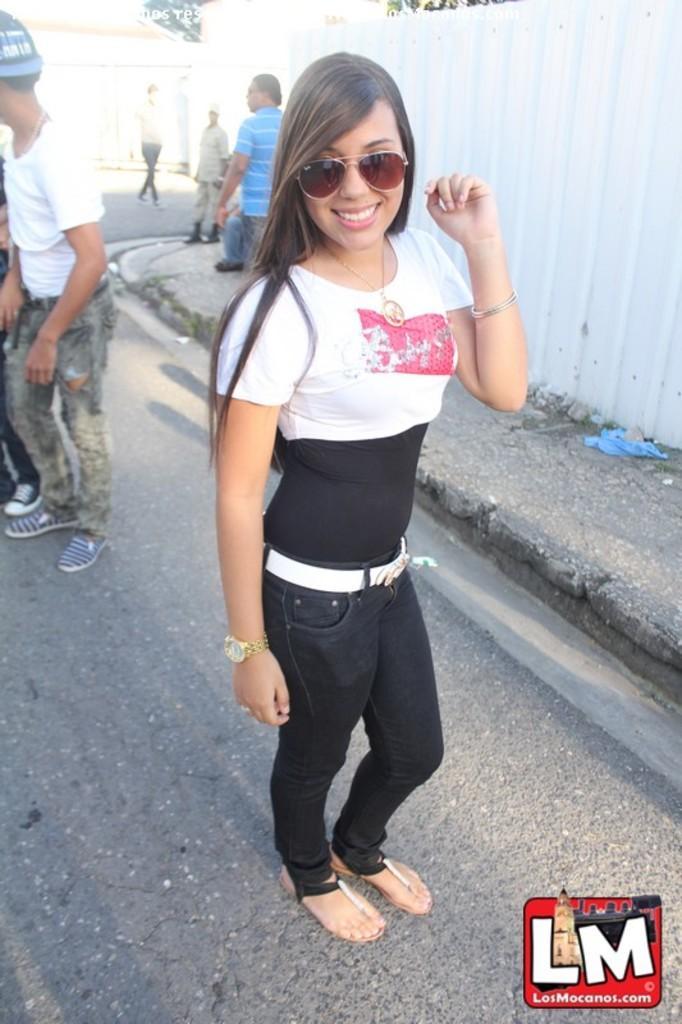How would you summarize this image in a sentence or two? In the center of the picture there is a woman standing. On the left there are people standing. In the background there are people walking down the road. In the background there are trees and buildings. On the right there is a footpath. 